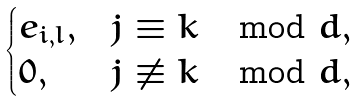<formula> <loc_0><loc_0><loc_500><loc_500>\begin{cases} e _ { i , l } , & j \equiv k \mod d , \\ 0 , & j \not \equiv k \mod d , \end{cases}</formula> 